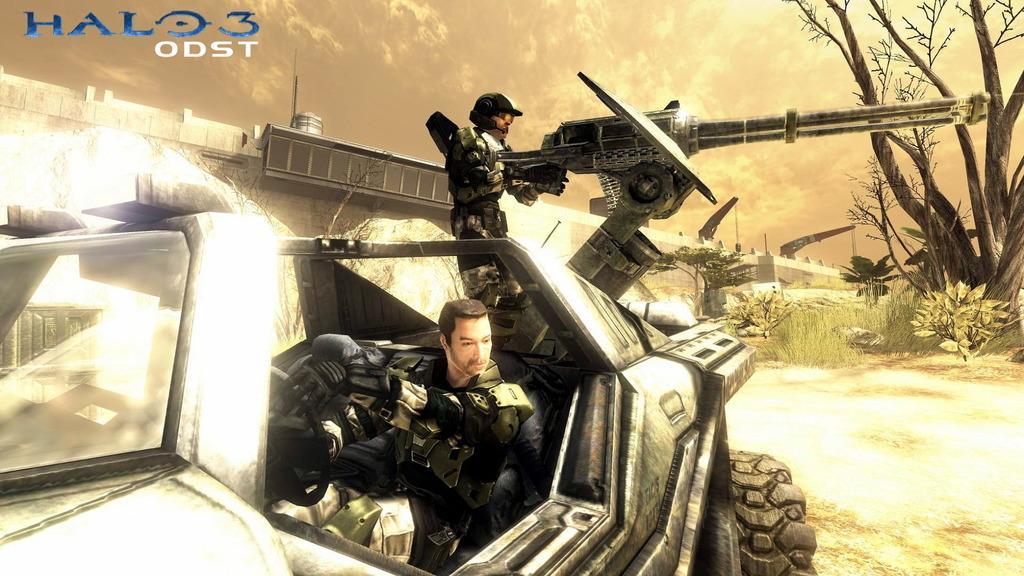Could you give a brief overview of what you see in this image? This is an animation picture. In this image there is a man sitting in the vehicle and there is a man standing and holding the object. At the back there is a bridge and there are trees and plants. At the top there is sky and there are clouds. At the bottom there is ground. At the top left there is text. 